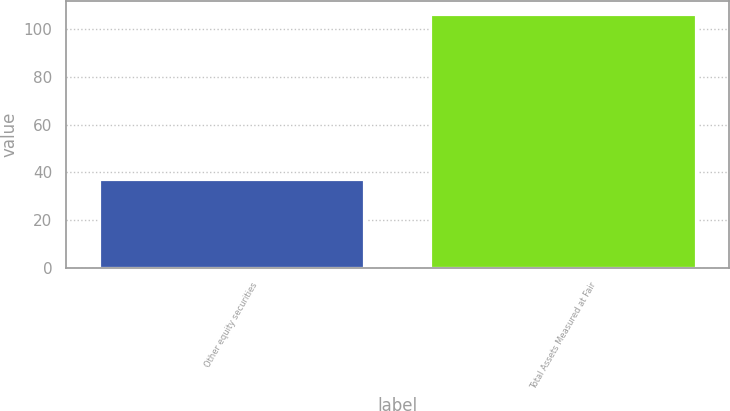Convert chart to OTSL. <chart><loc_0><loc_0><loc_500><loc_500><bar_chart><fcel>Other equity securities<fcel>Total Assets Measured at Fair<nl><fcel>37<fcel>106.4<nl></chart> 